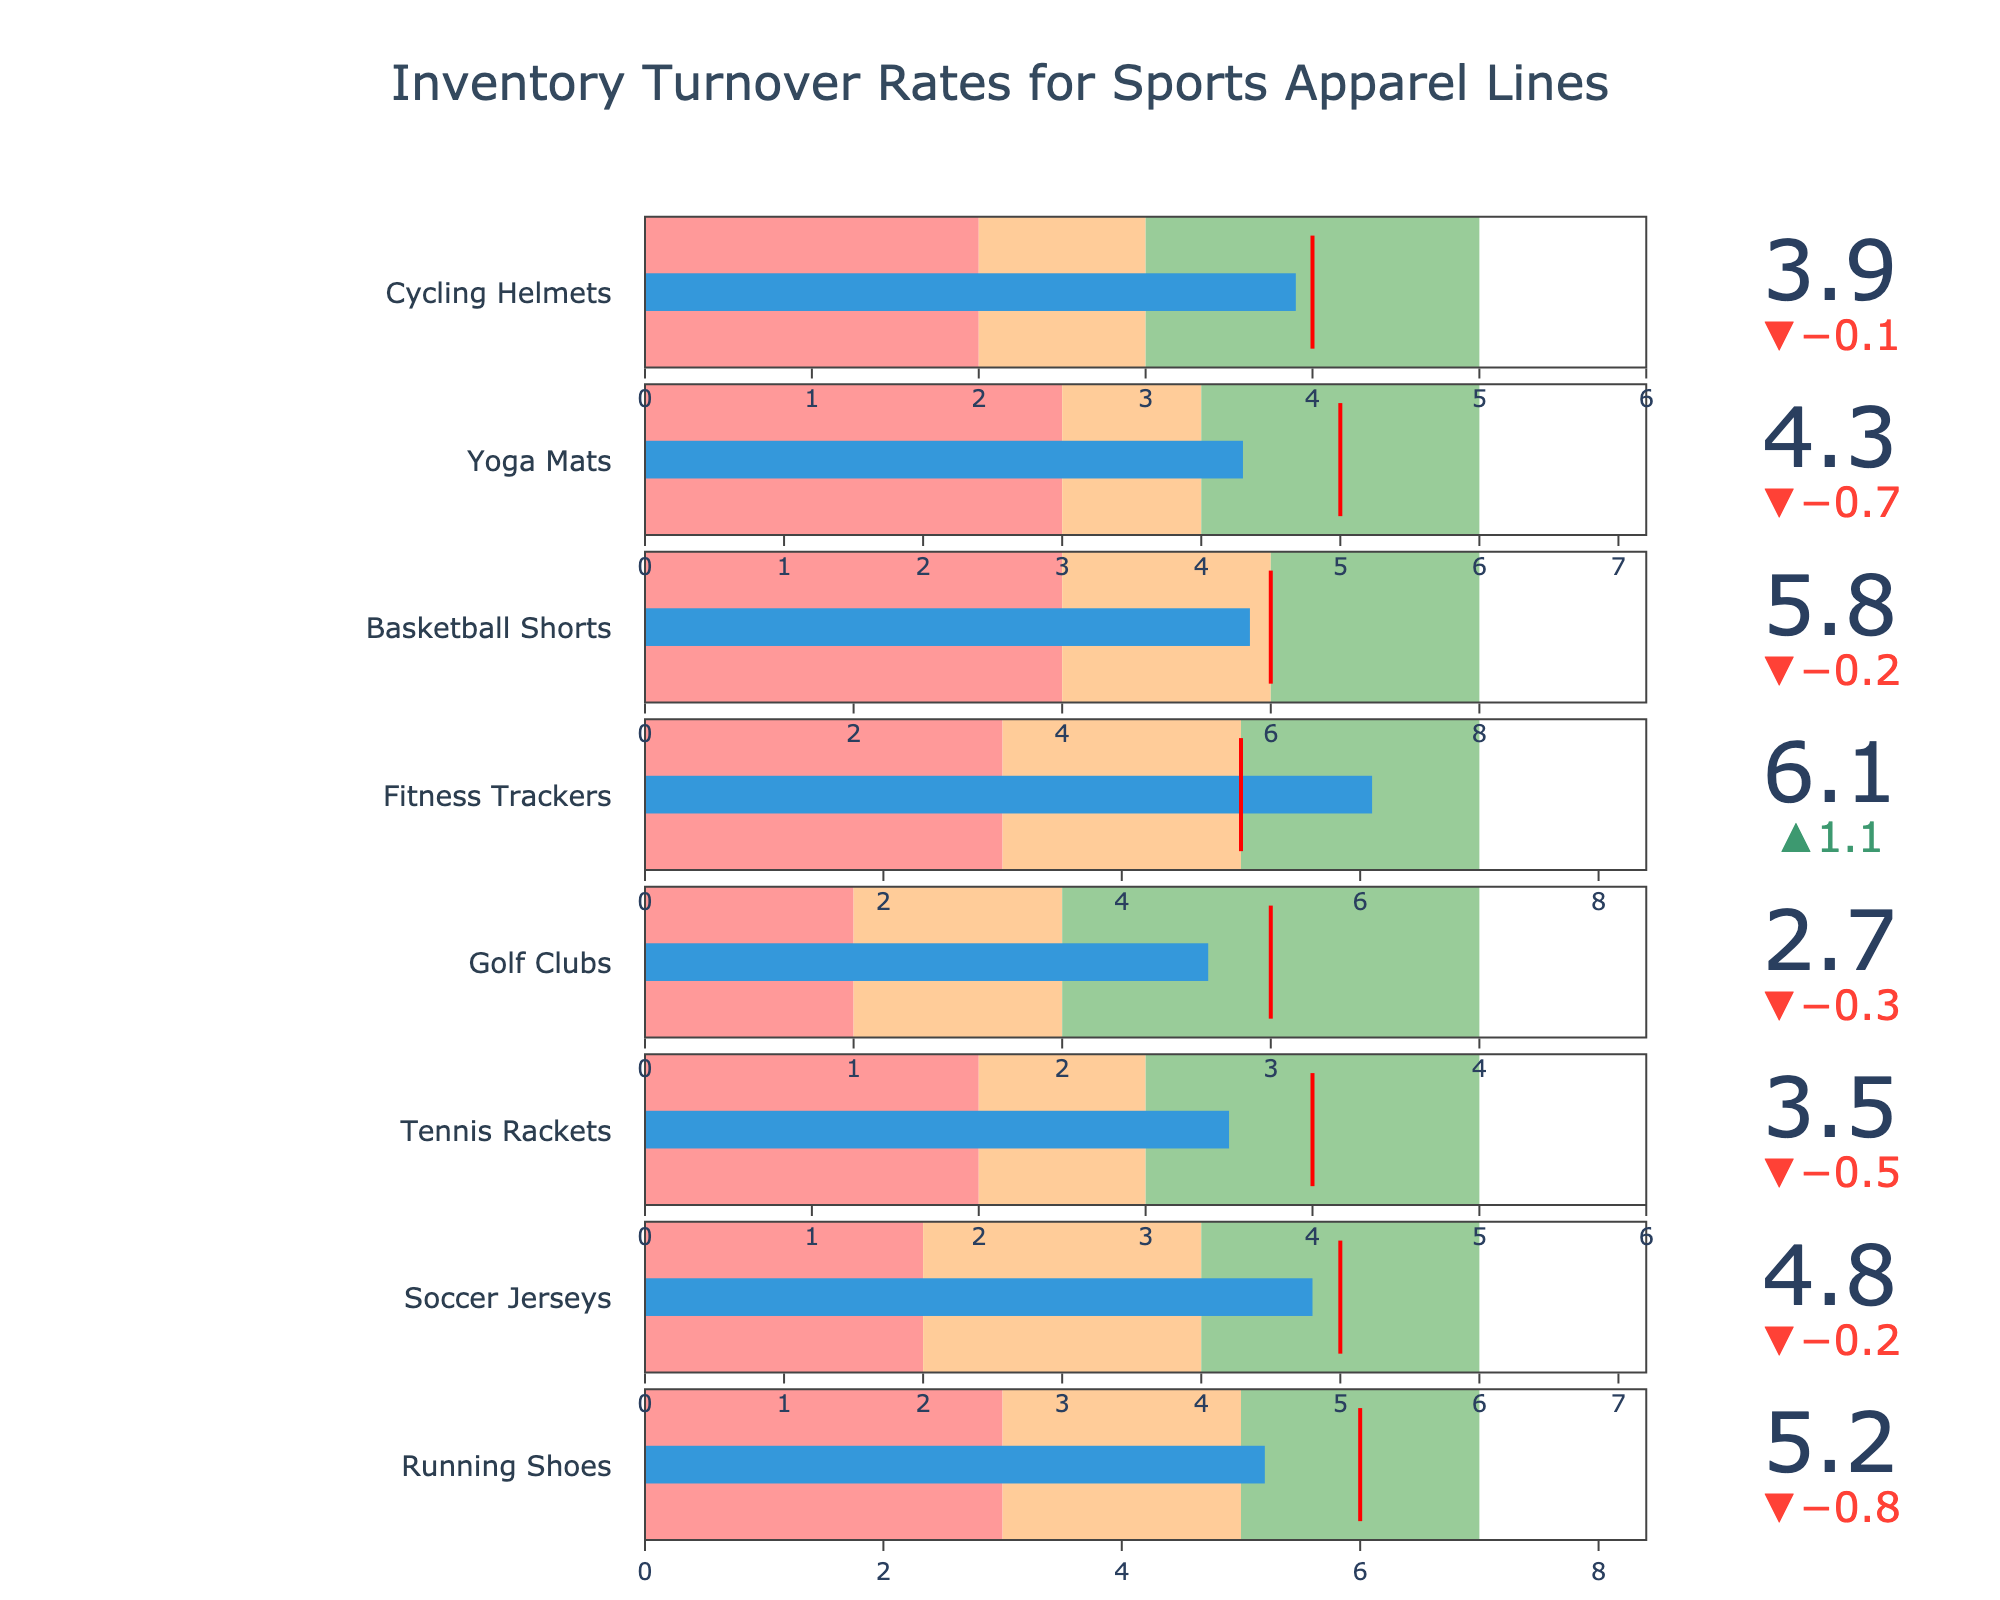what is the title of the figure? At the top of the figure, there is a title that describes the subject. The title is "Inventory Turnover Rates for Sports Apparel Lines".
Answer: Inventory Turnover Rates for Sports Apparel Lines How many categories of sports apparel are shown in the figure? By counting the number of different categories along the y-axis of the bullet charts, we see there are 8 categories.
Answer: 8 What is the actual inventory turnover rate for Running Shoes? For Running Shoes, the bullet chart shows the actual value, represented by a blue bar, as 5.2.
Answer: 5.2 Which category has the highest actual inventory turnover rate? By examining all the bullet charts, Fitness Trackers have the highest actual value, represented by a blue bar, which is 6.1.
Answer: Fitness Trackers What is the difference between the actual and target inventory turnover rates for Basketball Shorts? The actual rate for Basketball Shorts is 5.8, and the target rate is 6. The difference is calculated by subtracting 5.8 from 6, which equals 0.2.
Answer: 0.2 For which categories are the actual inventory turnover rates below their target rates? Comparing the actual and target rates for each category, Running Shoes, Soccer Jerseys, Tennis Rackets, Golf Clubs, Basketball Shorts, Yoga Mats, and Cycling Helmets are below their target rates.
Answer: 7 categories Which categories have their actual inventory turnover rate within the "Good" performance range? For categories where the blue bar (actual value) falls within the green "Good" performance range, these would be Fitness Trackers and Basketball Shorts.
Answer: Fitness Trackers, Basketball Shorts What is the range for "Satisfactory" performance for Cycling Helmets? The "Satisfactory" performance range of the bullet chart for Cycling Helmets is indicated by the orange area, between the "Poor" and "Good" ranges. It spans from 3 to 4.
Answer: 3 to 4 What is the median target value for all the categories? First, list all target values: 6, 5, 4, 3, 5, 6, 5, 4. Arranging them in sorted order gives 3, 4, 4, 5, 5, 5, 6, 6. The median is the average of the two middle values (5 and 5).
Answer: 5 Which category has the greatest difference between its "Poor" and "Good" performance ranges? By calculating the differences for each category: Running Shoes (7-3=4), Soccer Jerseys (6-2=4), Tennis Rackets (5-2=3), Golf Clubs (4-1=3), Fitness Trackers (7-3=4), Basketball Shorts (8-4=4), Yoga Mats (6-3=3), Cycling Helmets (5-2=3). Several categories have the highest difference of 4.
Answer: Running Shoes, Soccer Jerseys, Fitness Trackers, Basketball Shorts 